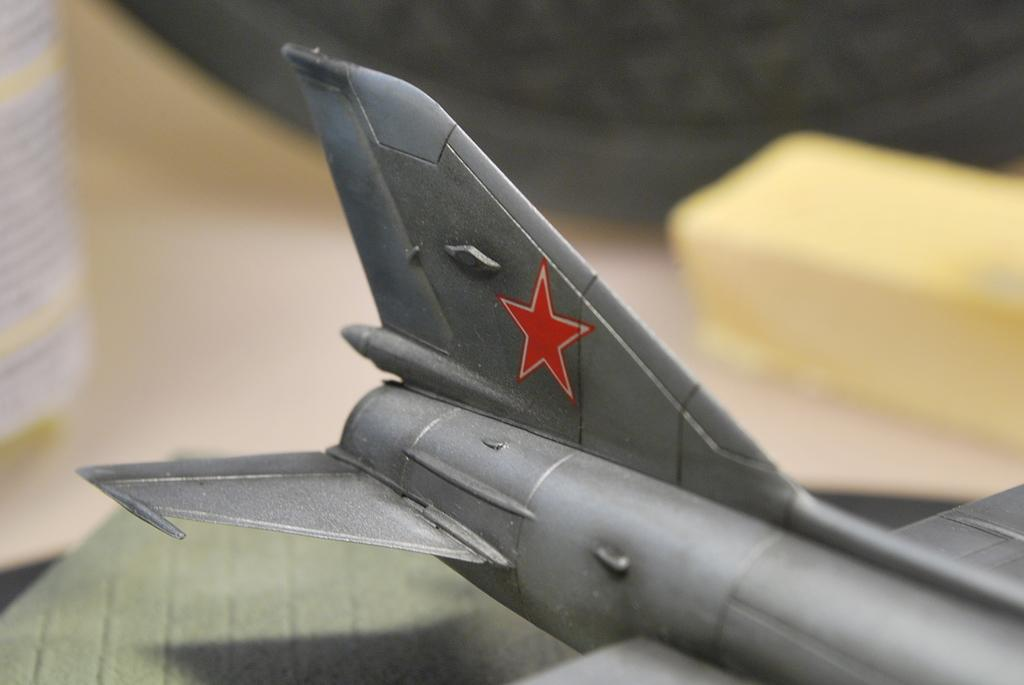What type of object can be seen in the image? There is a toy in the image. Can you describe the color of the toy? The toy is ash colored. What is the surface at the bottom of the image? The surface at the bottom of the image is not specified, but it could be a floor, table, or other flat surface. How would you describe the background of the image? The background of the image has a blurred view. How many objects are visible in the image? There are a few objects visible in the image. What type of canvas is the toy painted on in the image? There is no canvas present in the image, and the toy is not depicted as being painted on any surface. 